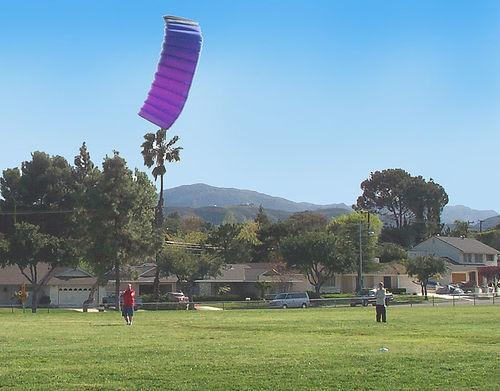What does the man in red hold in his hands? Please explain your reasoning. kite strings. Due to the purple kite above him you can easily tell what he is holding. 